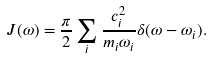Convert formula to latex. <formula><loc_0><loc_0><loc_500><loc_500>J ( \omega ) = \frac { \pi } { 2 } \sum _ { i } \frac { c _ { i } ^ { 2 } } { m _ { i } \omega _ { i } } \delta ( \omega - \omega _ { i } ) .</formula> 